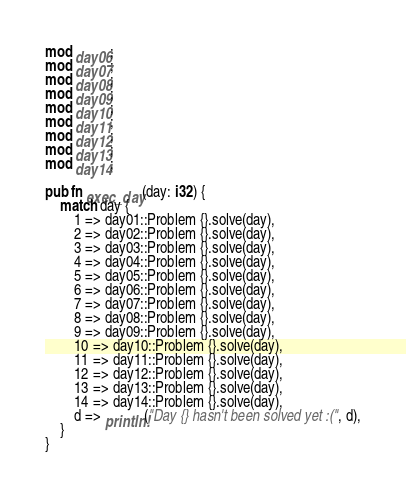Convert code to text. <code><loc_0><loc_0><loc_500><loc_500><_Rust_>mod day06;
mod day07;
mod day08;
mod day09;
mod day10;
mod day11;
mod day12;
mod day13;
mod day14;

pub fn exec_day(day: i32) {
    match day {
        1 => day01::Problem {}.solve(day),
        2 => day02::Problem {}.solve(day),
        3 => day03::Problem {}.solve(day),
        4 => day04::Problem {}.solve(day),
        5 => day05::Problem {}.solve(day),
        6 => day06::Problem {}.solve(day),
        7 => day07::Problem {}.solve(day),
        8 => day08::Problem {}.solve(day),
        9 => day09::Problem {}.solve(day),
        10 => day10::Problem {}.solve(day),
        11 => day11::Problem {}.solve(day),
        12 => day12::Problem {}.solve(day),
        13 => day13::Problem {}.solve(day),
        14 => day14::Problem {}.solve(day),
        d => println!("Day {} hasn't been solved yet :(", d),
    }
}
</code> 